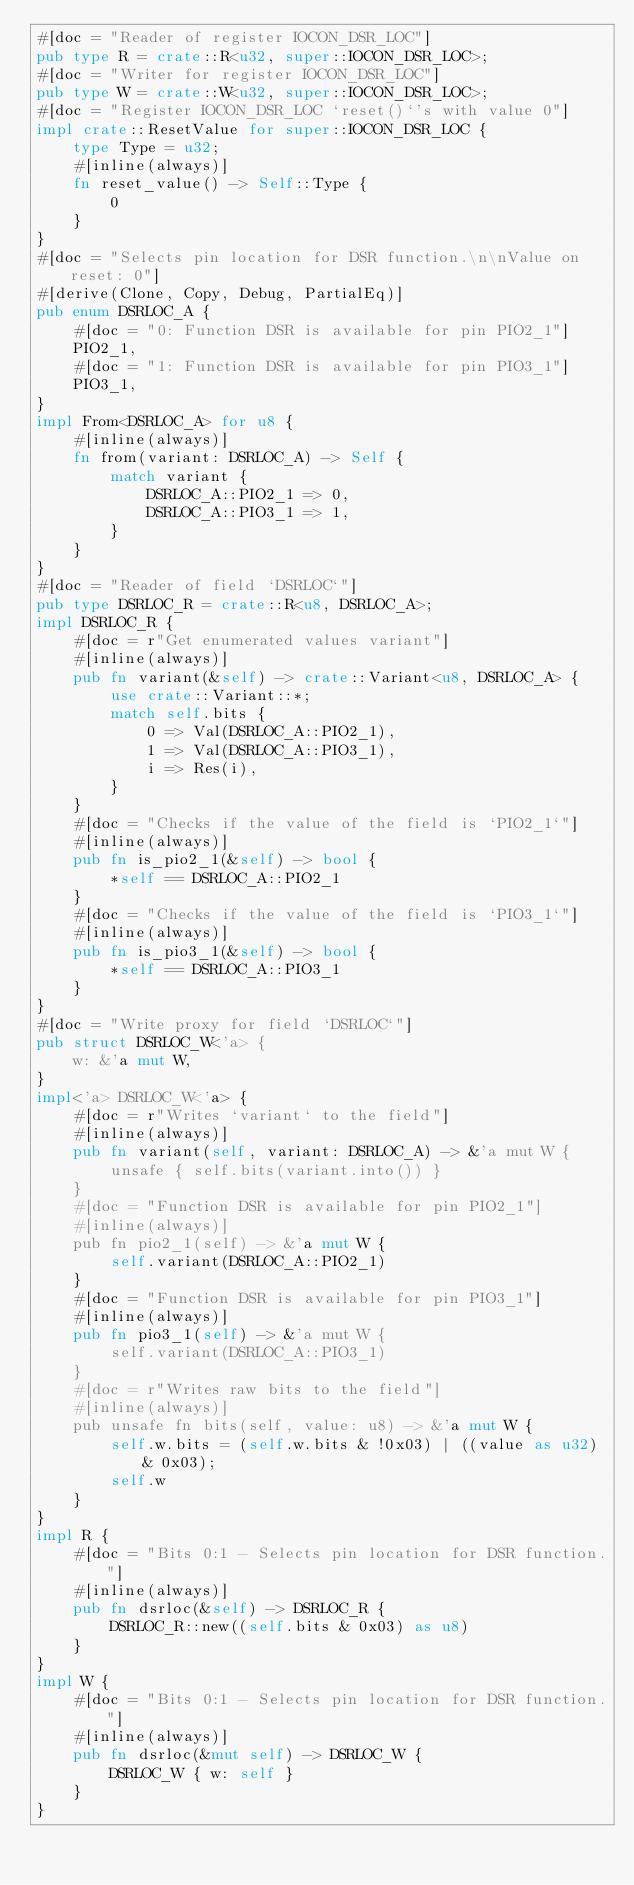Convert code to text. <code><loc_0><loc_0><loc_500><loc_500><_Rust_>#[doc = "Reader of register IOCON_DSR_LOC"]
pub type R = crate::R<u32, super::IOCON_DSR_LOC>;
#[doc = "Writer for register IOCON_DSR_LOC"]
pub type W = crate::W<u32, super::IOCON_DSR_LOC>;
#[doc = "Register IOCON_DSR_LOC `reset()`'s with value 0"]
impl crate::ResetValue for super::IOCON_DSR_LOC {
    type Type = u32;
    #[inline(always)]
    fn reset_value() -> Self::Type {
        0
    }
}
#[doc = "Selects pin location for DSR function.\n\nValue on reset: 0"]
#[derive(Clone, Copy, Debug, PartialEq)]
pub enum DSRLOC_A {
    #[doc = "0: Function DSR is available for pin PIO2_1"]
    PIO2_1,
    #[doc = "1: Function DSR is available for pin PIO3_1"]
    PIO3_1,
}
impl From<DSRLOC_A> for u8 {
    #[inline(always)]
    fn from(variant: DSRLOC_A) -> Self {
        match variant {
            DSRLOC_A::PIO2_1 => 0,
            DSRLOC_A::PIO3_1 => 1,
        }
    }
}
#[doc = "Reader of field `DSRLOC`"]
pub type DSRLOC_R = crate::R<u8, DSRLOC_A>;
impl DSRLOC_R {
    #[doc = r"Get enumerated values variant"]
    #[inline(always)]
    pub fn variant(&self) -> crate::Variant<u8, DSRLOC_A> {
        use crate::Variant::*;
        match self.bits {
            0 => Val(DSRLOC_A::PIO2_1),
            1 => Val(DSRLOC_A::PIO3_1),
            i => Res(i),
        }
    }
    #[doc = "Checks if the value of the field is `PIO2_1`"]
    #[inline(always)]
    pub fn is_pio2_1(&self) -> bool {
        *self == DSRLOC_A::PIO2_1
    }
    #[doc = "Checks if the value of the field is `PIO3_1`"]
    #[inline(always)]
    pub fn is_pio3_1(&self) -> bool {
        *self == DSRLOC_A::PIO3_1
    }
}
#[doc = "Write proxy for field `DSRLOC`"]
pub struct DSRLOC_W<'a> {
    w: &'a mut W,
}
impl<'a> DSRLOC_W<'a> {
    #[doc = r"Writes `variant` to the field"]
    #[inline(always)]
    pub fn variant(self, variant: DSRLOC_A) -> &'a mut W {
        unsafe { self.bits(variant.into()) }
    }
    #[doc = "Function DSR is available for pin PIO2_1"]
    #[inline(always)]
    pub fn pio2_1(self) -> &'a mut W {
        self.variant(DSRLOC_A::PIO2_1)
    }
    #[doc = "Function DSR is available for pin PIO3_1"]
    #[inline(always)]
    pub fn pio3_1(self) -> &'a mut W {
        self.variant(DSRLOC_A::PIO3_1)
    }
    #[doc = r"Writes raw bits to the field"]
    #[inline(always)]
    pub unsafe fn bits(self, value: u8) -> &'a mut W {
        self.w.bits = (self.w.bits & !0x03) | ((value as u32) & 0x03);
        self.w
    }
}
impl R {
    #[doc = "Bits 0:1 - Selects pin location for DSR function."]
    #[inline(always)]
    pub fn dsrloc(&self) -> DSRLOC_R {
        DSRLOC_R::new((self.bits & 0x03) as u8)
    }
}
impl W {
    #[doc = "Bits 0:1 - Selects pin location for DSR function."]
    #[inline(always)]
    pub fn dsrloc(&mut self) -> DSRLOC_W {
        DSRLOC_W { w: self }
    }
}
</code> 